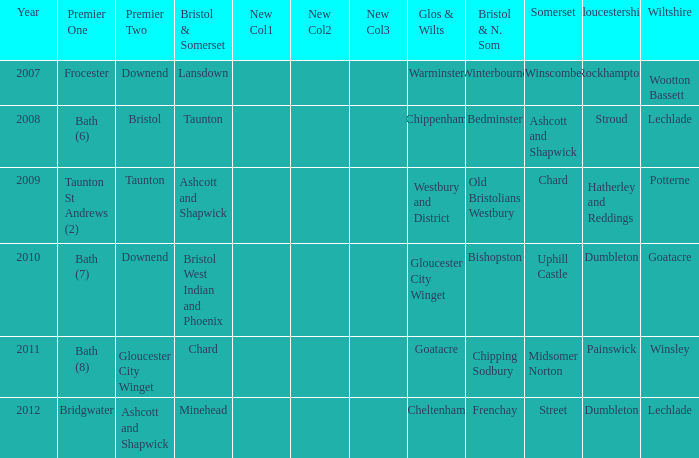What is the year where glos & wilts is gloucester city winget? 2010.0. 